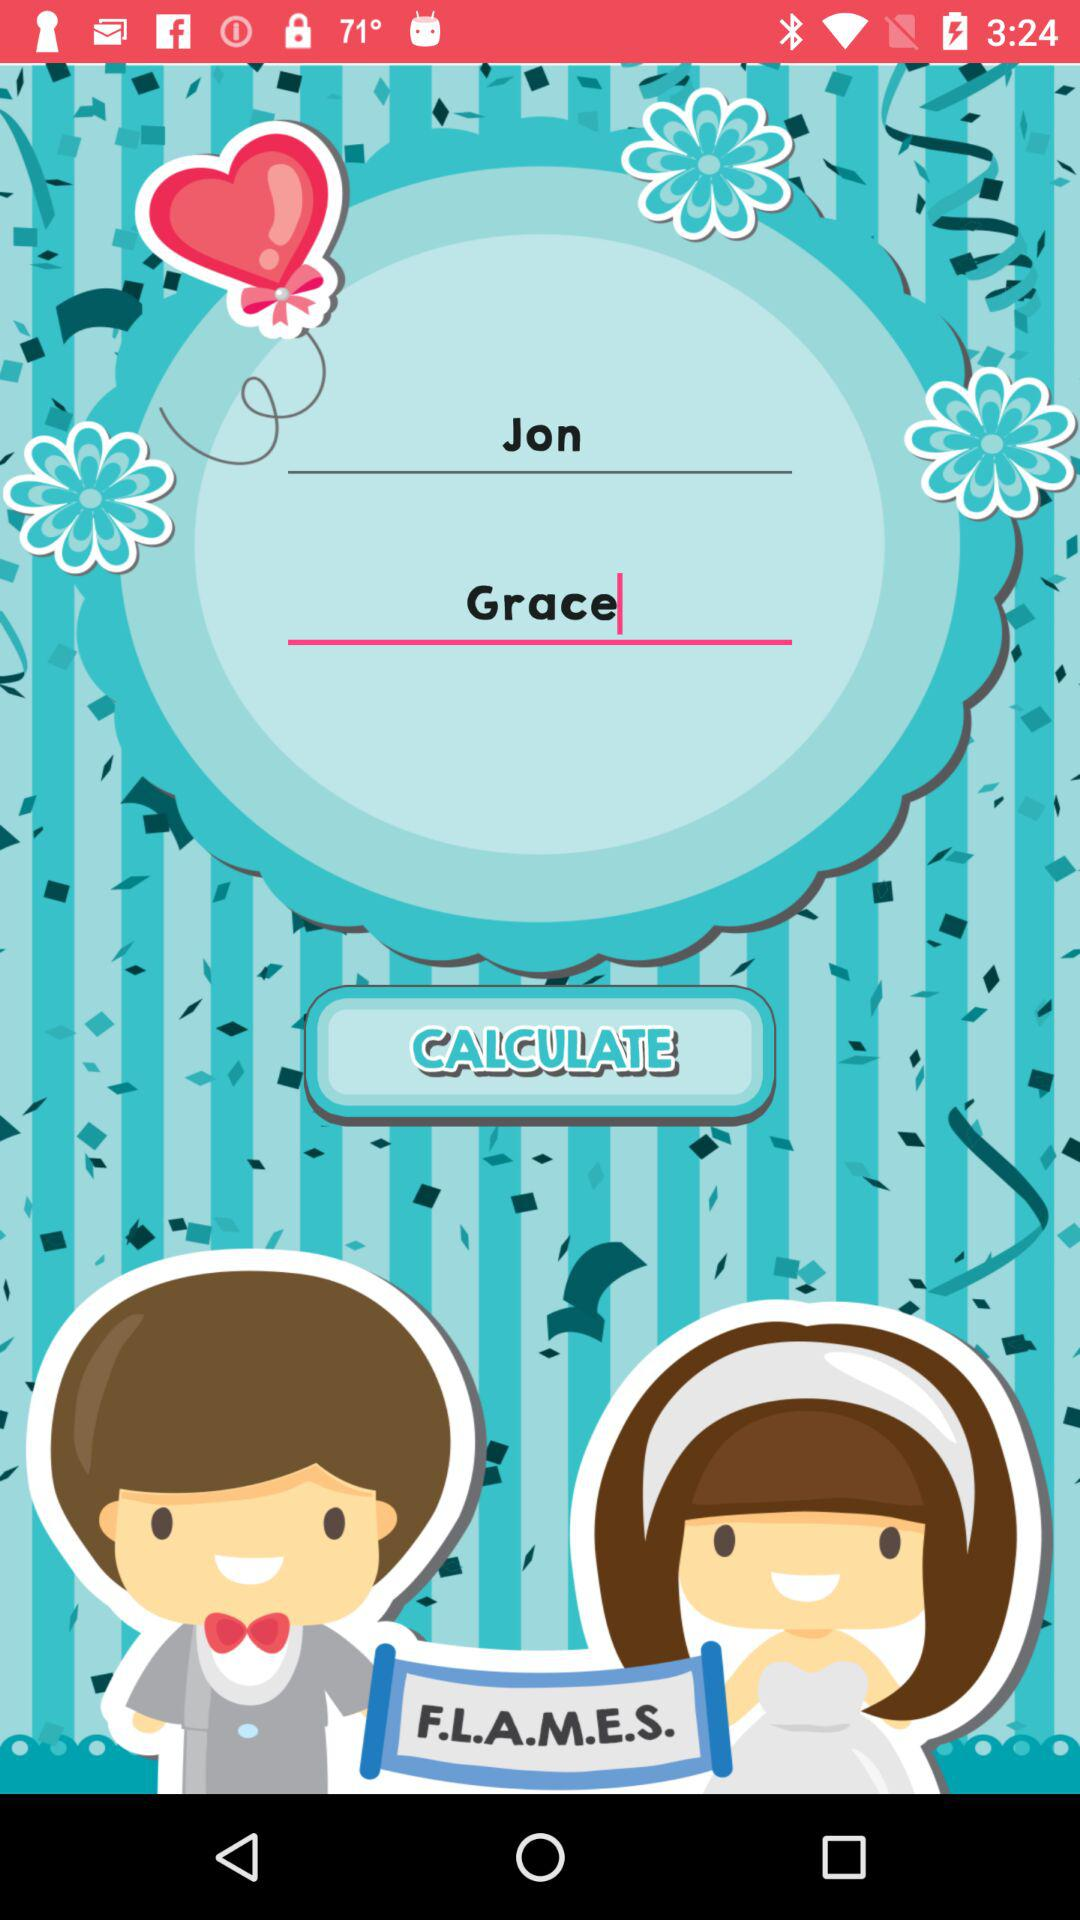What is the name of the girl? The name of the girl is Grace. 